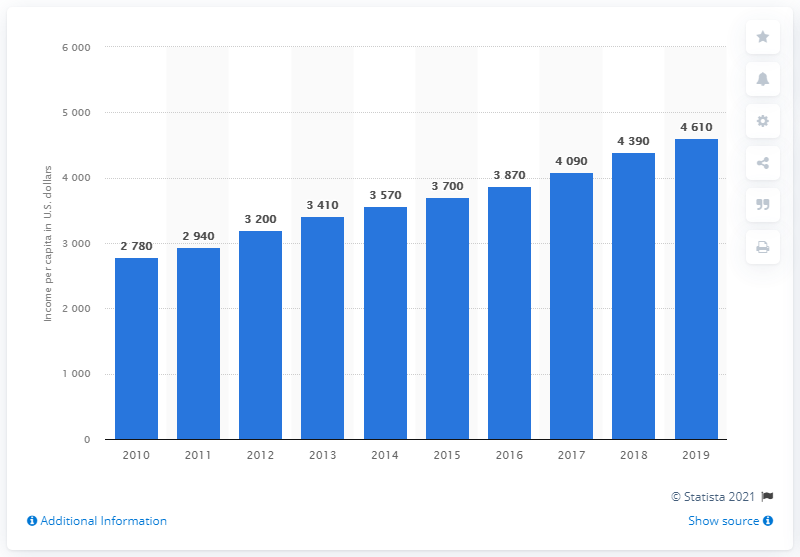Mention a couple of crucial points in this snapshot. In 2019, the national gross income per capita in Guatemala was 4,610. 